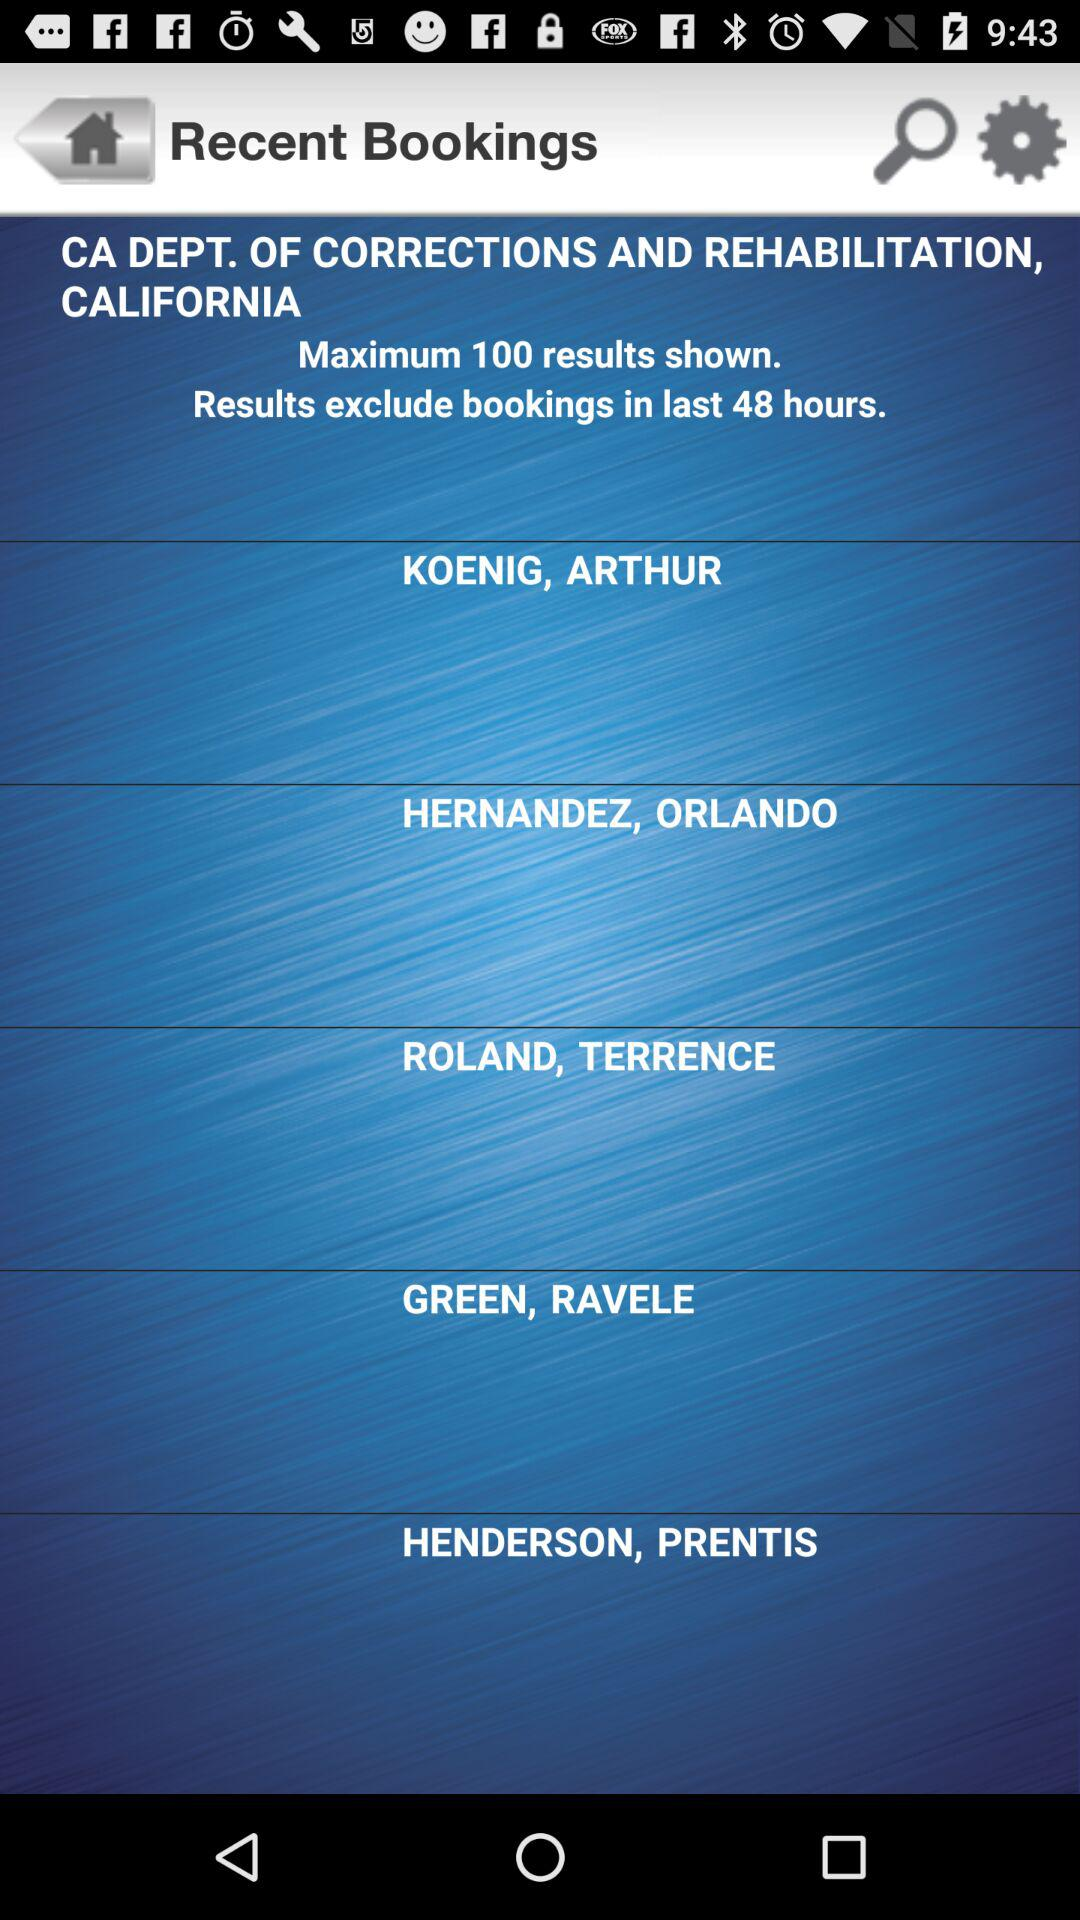What is the name of the department? The name of the department is "CA DEPT. OF CORRECTIONS AND REHABILITATION, CALIFORNIA". 